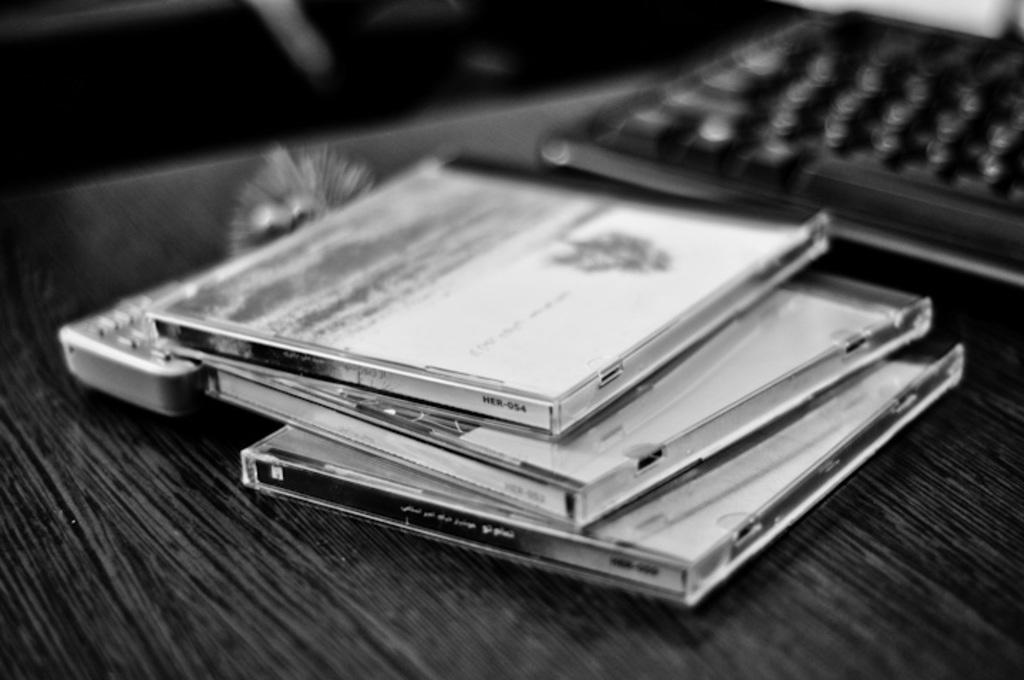<image>
Describe the image concisely. Three CDs, one that says HER-054, on the side are stacked on a desk in a black and white photo. 